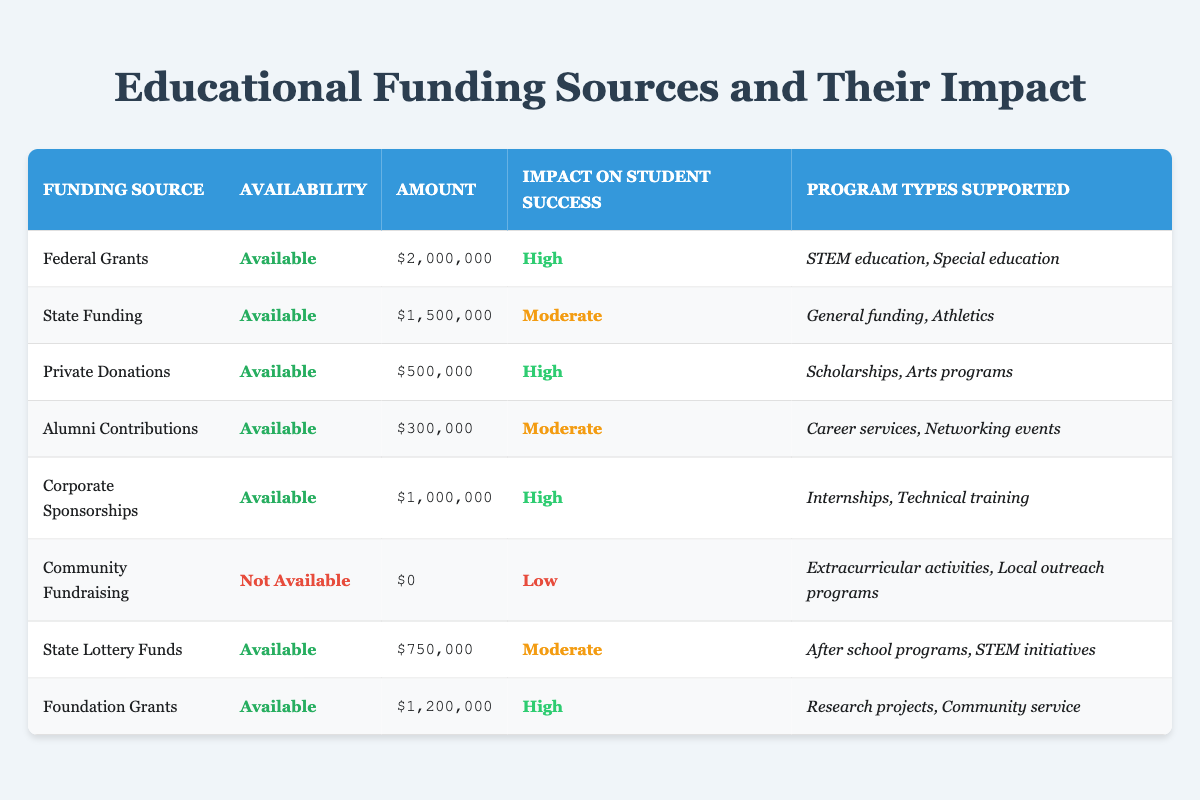What is the total amount of funding from High impact sources? The high impact sources are Federal Grants, Private Donations, Corporate Sponsorships, and Foundation Grants. Their amounts are $2,000,000, $500,000, $1,000,000, and $1,200,000 respectively. Adding these amounts gives: 2,000,000 + 500,000 + 1,000,000 + 1,200,000 = 4,700,000.
Answer: 4,700,000 Is Community Fundraising available? The availability status for Community Fundraising is indicated in the table as "Not Available."
Answer: No Which funding source has the lowest amount? The lowest amount is shown for Community Fundraising, which is $0.
Answer: $0 How many funding sources have a Moderate impact on student success? The funding sources with a Moderate impact are State Funding, Alumni Contributions, and State Lottery Funds. Counting these, we find there are 3 sources.
Answer: 3 What is the difference in funding amount between the highest and lowest sources? The highest funding source is Federal Grants with $2,000,000, and the lowest is Community Fundraising with $0. The difference is calculated as: 2,000,000 - 0 = 2,000,000.
Answer: 2,000,000 Does State Funding provide more or less than $1,000,000? State Funding has an amount of $1,500,000, which is greater than $1,000,000.
Answer: More What types of programs are supported by the funding source with the highest amount? Federal Grants, which has the highest amount of $2,000,000, supports STEM education and Special education as shown in the table.
Answer: STEM education, Special education How much total funding is available from sources that support Extracurricular activities and Local outreach programs? Community Fundraising is the only source that supports Extracurricular activities and Local outreach programs, and it has an amount of $0. Therefore, the total amount available is $0.
Answer: $0 What is the average funding amount from all available sources? The available funding sources are Federal Grants ($2,000,000), State Funding ($1,500,000), Private Donations ($500,000), Alumni Contributions ($300,000), Corporate Sponsorships ($1,000,000), State Lottery Funds ($750,000), and Foundation Grants ($1,200,000). Summing these gives: 2,000,000 + 1,500,000 + 500,000 + 300,000 + 1,000,000 + 750,000 + 1,200,000 = 7,250,000. There are 7 available sources, so the average is 7,250,000 / 7 = 1,035,714.29.
Answer: 1,035,714.29 